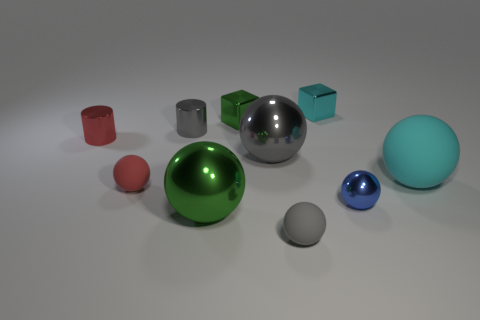Subtract all blue balls. How many balls are left? 5 Subtract all large gray balls. How many balls are left? 5 Subtract all cyan balls. Subtract all brown blocks. How many balls are left? 5 Subtract all cubes. How many objects are left? 8 Add 2 cyan metal objects. How many cyan metal objects are left? 3 Add 3 tiny gray metallic cylinders. How many tiny gray metallic cylinders exist? 4 Subtract 1 blue balls. How many objects are left? 9 Subtract all blue metal objects. Subtract all tiny gray metal cylinders. How many objects are left? 8 